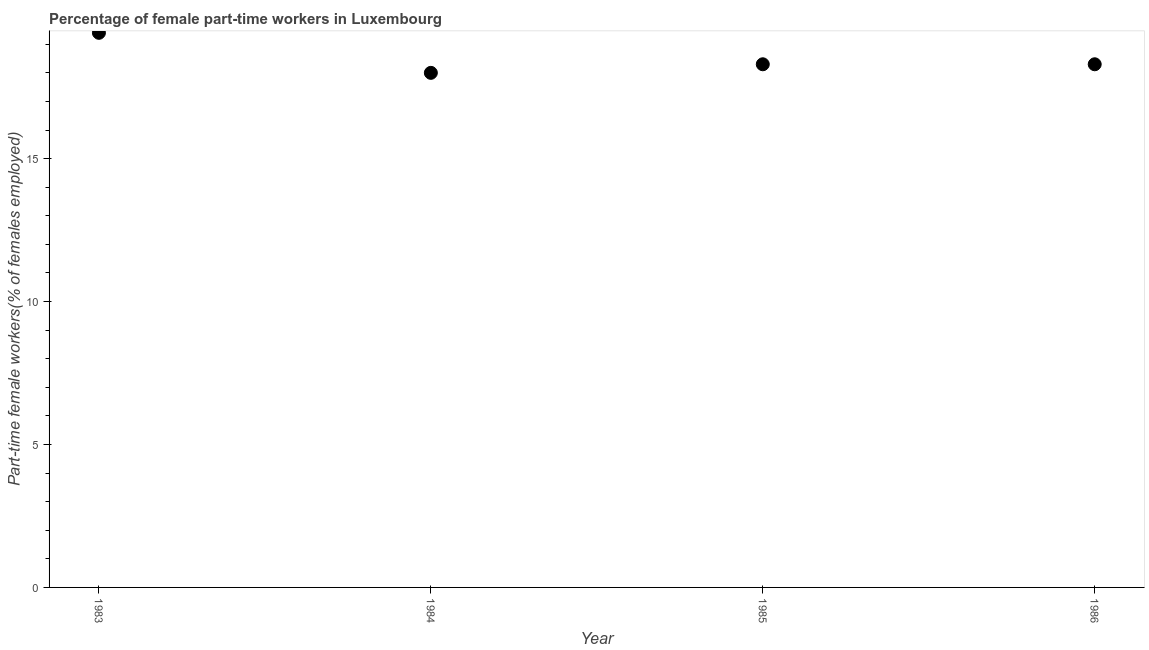What is the percentage of part-time female workers in 1985?
Ensure brevity in your answer.  18.3. Across all years, what is the maximum percentage of part-time female workers?
Your answer should be very brief. 19.4. What is the sum of the percentage of part-time female workers?
Your answer should be very brief. 74. What is the difference between the percentage of part-time female workers in 1983 and 1984?
Your answer should be compact. 1.4. What is the average percentage of part-time female workers per year?
Provide a short and direct response. 18.5. What is the median percentage of part-time female workers?
Provide a succinct answer. 18.3. What is the ratio of the percentage of part-time female workers in 1984 to that in 1986?
Give a very brief answer. 0.98. What is the difference between the highest and the second highest percentage of part-time female workers?
Offer a very short reply. 1.1. What is the difference between the highest and the lowest percentage of part-time female workers?
Provide a short and direct response. 1.4. In how many years, is the percentage of part-time female workers greater than the average percentage of part-time female workers taken over all years?
Ensure brevity in your answer.  1. Does the percentage of part-time female workers monotonically increase over the years?
Your response must be concise. No. How many dotlines are there?
Provide a succinct answer. 1. How many years are there in the graph?
Offer a very short reply. 4. What is the difference between two consecutive major ticks on the Y-axis?
Make the answer very short. 5. Are the values on the major ticks of Y-axis written in scientific E-notation?
Keep it short and to the point. No. Does the graph contain any zero values?
Provide a short and direct response. No. Does the graph contain grids?
Your answer should be very brief. No. What is the title of the graph?
Keep it short and to the point. Percentage of female part-time workers in Luxembourg. What is the label or title of the X-axis?
Your answer should be compact. Year. What is the label or title of the Y-axis?
Your response must be concise. Part-time female workers(% of females employed). What is the Part-time female workers(% of females employed) in 1983?
Your answer should be very brief. 19.4. What is the Part-time female workers(% of females employed) in 1985?
Keep it short and to the point. 18.3. What is the Part-time female workers(% of females employed) in 1986?
Provide a succinct answer. 18.3. What is the difference between the Part-time female workers(% of females employed) in 1983 and 1984?
Your answer should be very brief. 1.4. What is the difference between the Part-time female workers(% of females employed) in 1984 and 1986?
Ensure brevity in your answer.  -0.3. What is the difference between the Part-time female workers(% of females employed) in 1985 and 1986?
Ensure brevity in your answer.  0. What is the ratio of the Part-time female workers(% of females employed) in 1983 to that in 1984?
Give a very brief answer. 1.08. What is the ratio of the Part-time female workers(% of females employed) in 1983 to that in 1985?
Ensure brevity in your answer.  1.06. What is the ratio of the Part-time female workers(% of females employed) in 1983 to that in 1986?
Provide a short and direct response. 1.06. What is the ratio of the Part-time female workers(% of females employed) in 1984 to that in 1985?
Your answer should be very brief. 0.98. 